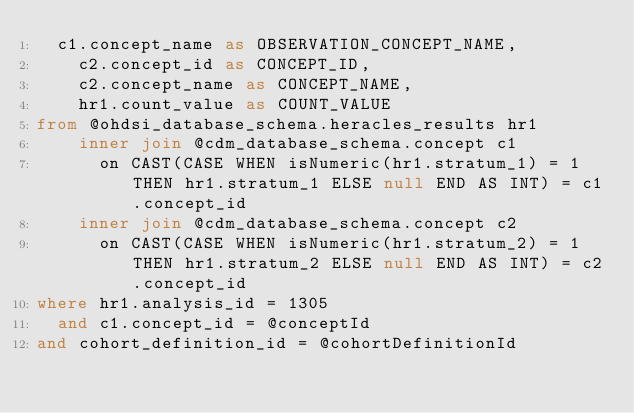Convert code to text. <code><loc_0><loc_0><loc_500><loc_500><_SQL_>  c1.concept_name as OBSERVATION_CONCEPT_NAME, 
	c2.concept_id as CONCEPT_ID,
	c2.concept_name as CONCEPT_NAME, 
	hr1.count_value as COUNT_VALUE
from @ohdsi_database_schema.heracles_results hr1
	inner join @cdm_database_schema.concept c1
	  on CAST(CASE WHEN isNumeric(hr1.stratum_1) = 1 THEN hr1.stratum_1 ELSE null END AS INT) = c1.concept_id
	inner join @cdm_database_schema.concept c2
	  on CAST(CASE WHEN isNumeric(hr1.stratum_2) = 1 THEN hr1.stratum_2 ELSE null END AS INT) = c2.concept_id
where hr1.analysis_id = 1305
  and c1.concept_id = @conceptId
and cohort_definition_id = @cohortDefinitionId</code> 